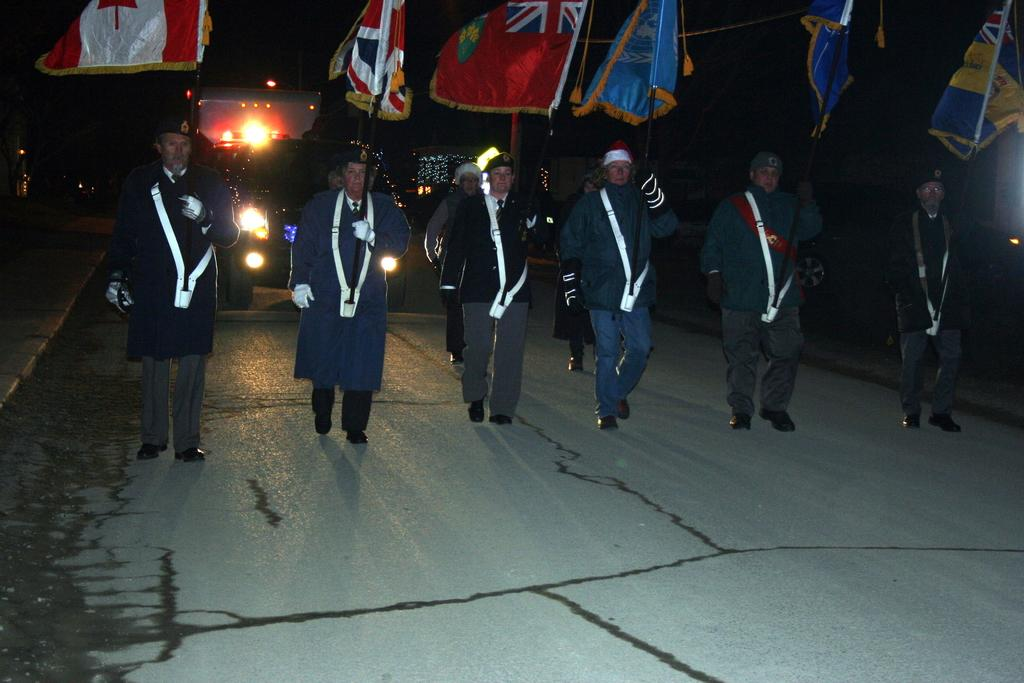What are the people in the image doing? The people in the image are walking on the road. What can be seen behind the people? There are vehicles behind the people. What are the people holding in their hands? The people are holding flags. What type of clothing are the people wearing on their heads? The people are wearing caps. What type of clothing are the people wearing on their bodies? The people are wearing uniforms. Where is the baby sleeping in the image? There is no baby present in the image. What type of sock can be seen on the people's feet in the image? There is no sock visible in the image; the people are wearing shoes or boots. 